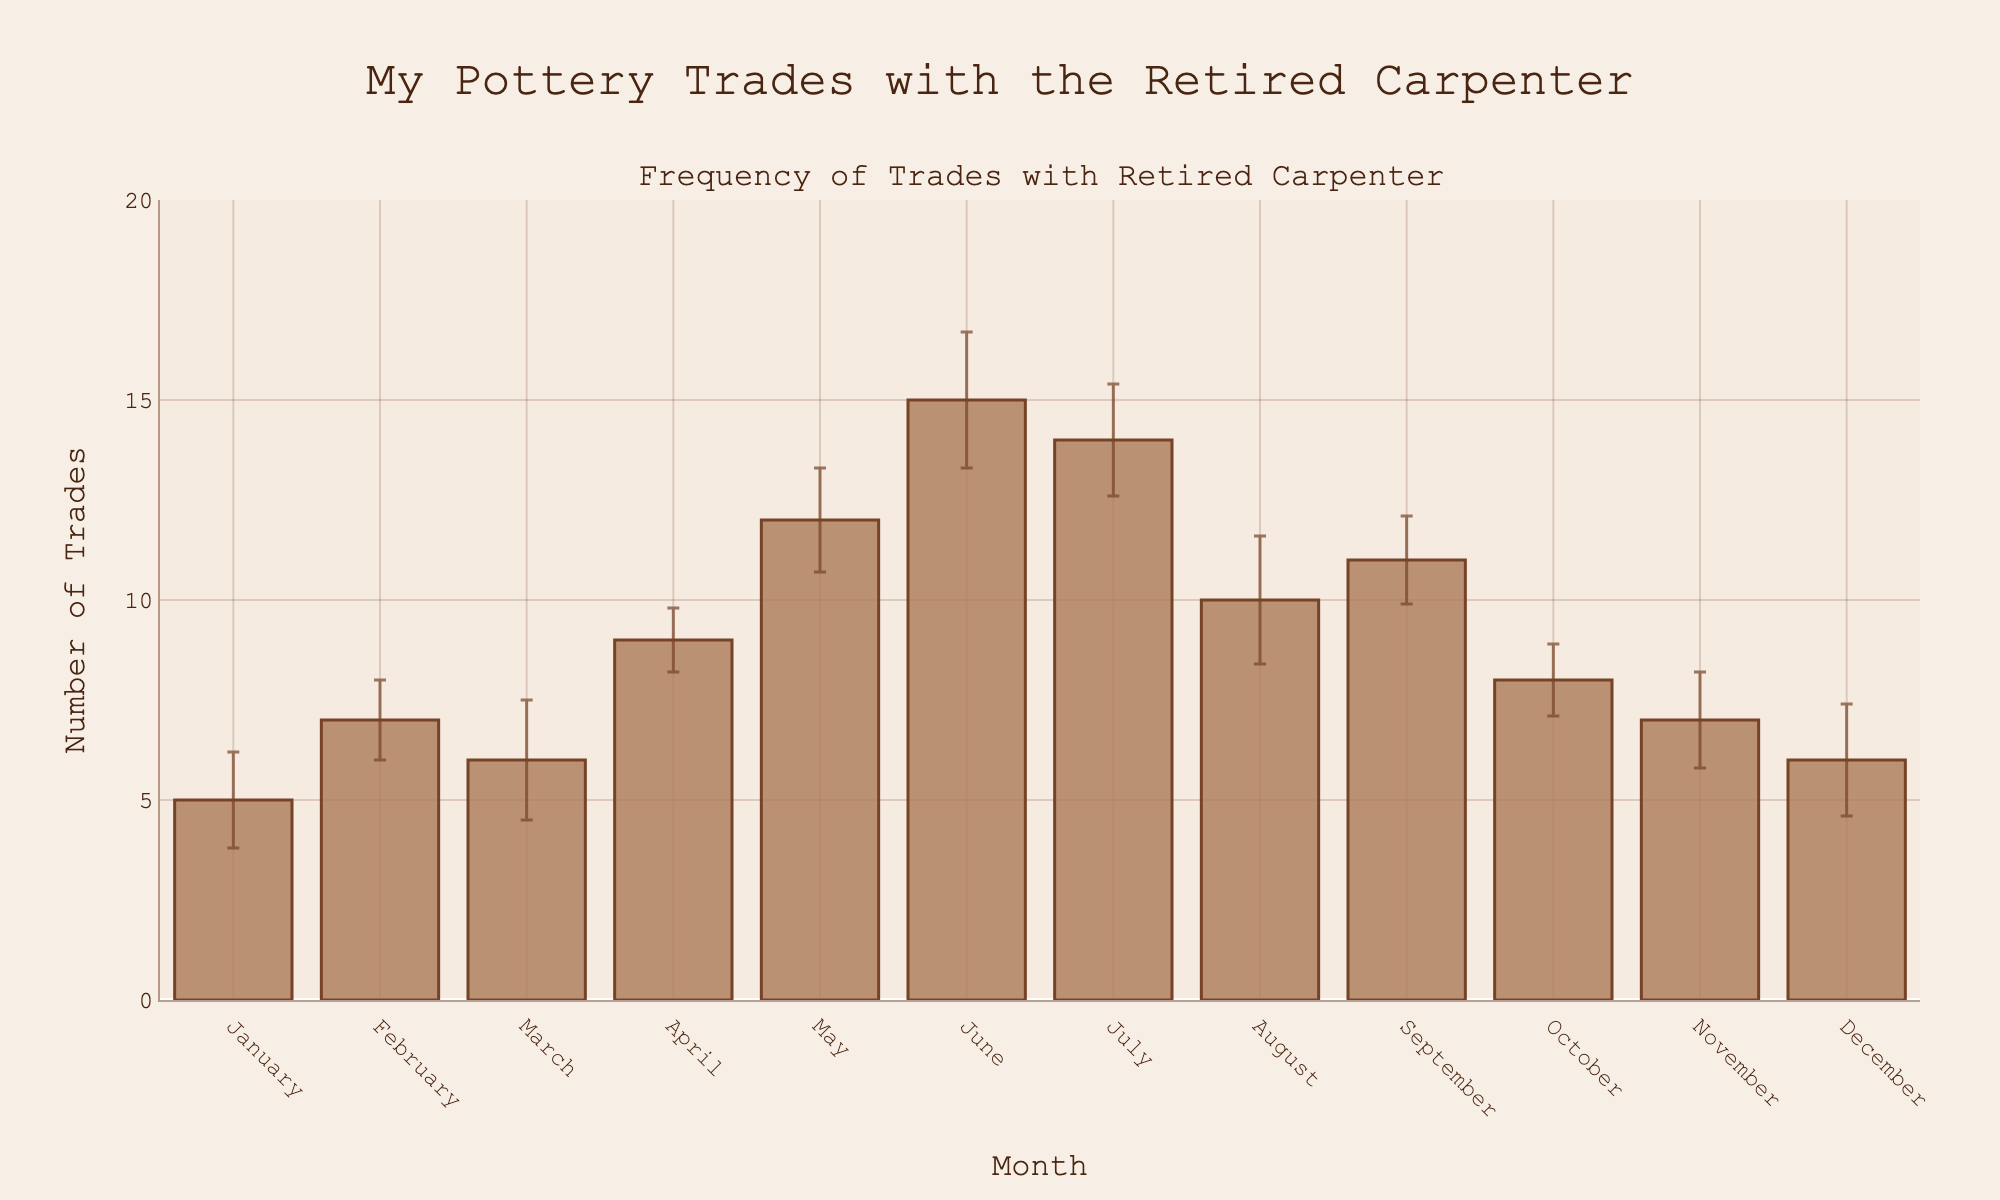What is the title of the plot? The title of the plot is displayed at the top and reads, "My Pottery Trades with the Retired Carpenter".
Answer: My Pottery Trades with the Retired Carpenter Which month has the highest number of trades? By looking at the height of the bars, June has the highest bar, representing the highest number of trades.
Answer: June What is the number of trades in August, and what is its standard deviation? In August, the bar height corresponds to 10 trades, and the error bar above it indicates a standard deviation of 1.6.
Answer: 10 trades, 1.6 What's the difference in the number of trades between June and December? The number of trades in June is 15 and in December is 6, so the difference is 15 - 6 = 9.
Answer: 9 Which month has the smallest error bar? By observing the vertical lines on top of the bars, April has the smallest error bar.
Answer: April Compare the number of trades in March and November. Which one is higher? By comparing the bar heights, March has a value of 6 trades, while November has 7. Therefore, November has a higher number of trades.
Answer: November What is the average number of trades for the first quarter of the year (January to March)? The first quarter includes January (5 trades), February (7 trades), and March (6 trades). The average is (5 + 7 + 6) / 3 = 6.
Answer: 6 How do the number of trades in May and July compare in relation to their error bars? May has 12 trades with a standard deviation of 1.3, and July has 14 trades with a standard deviation of 1.4. Both months have similar error bars, but July has a slightly higher number of trades.
Answer: July is slightly higher What is the range of the y-axis? The y-axis ranges from 0 to a value slightly above 15 to accommodate the highest data point plus some margin.
Answer: 0 to 20 In which months do the error bars overlap, indicating similar trade variability? By observing the vertical error bars, they overlap in February and March, and in May and June, indicating similar trade variability in these pairs of months.
Answer: February and March, May and June 